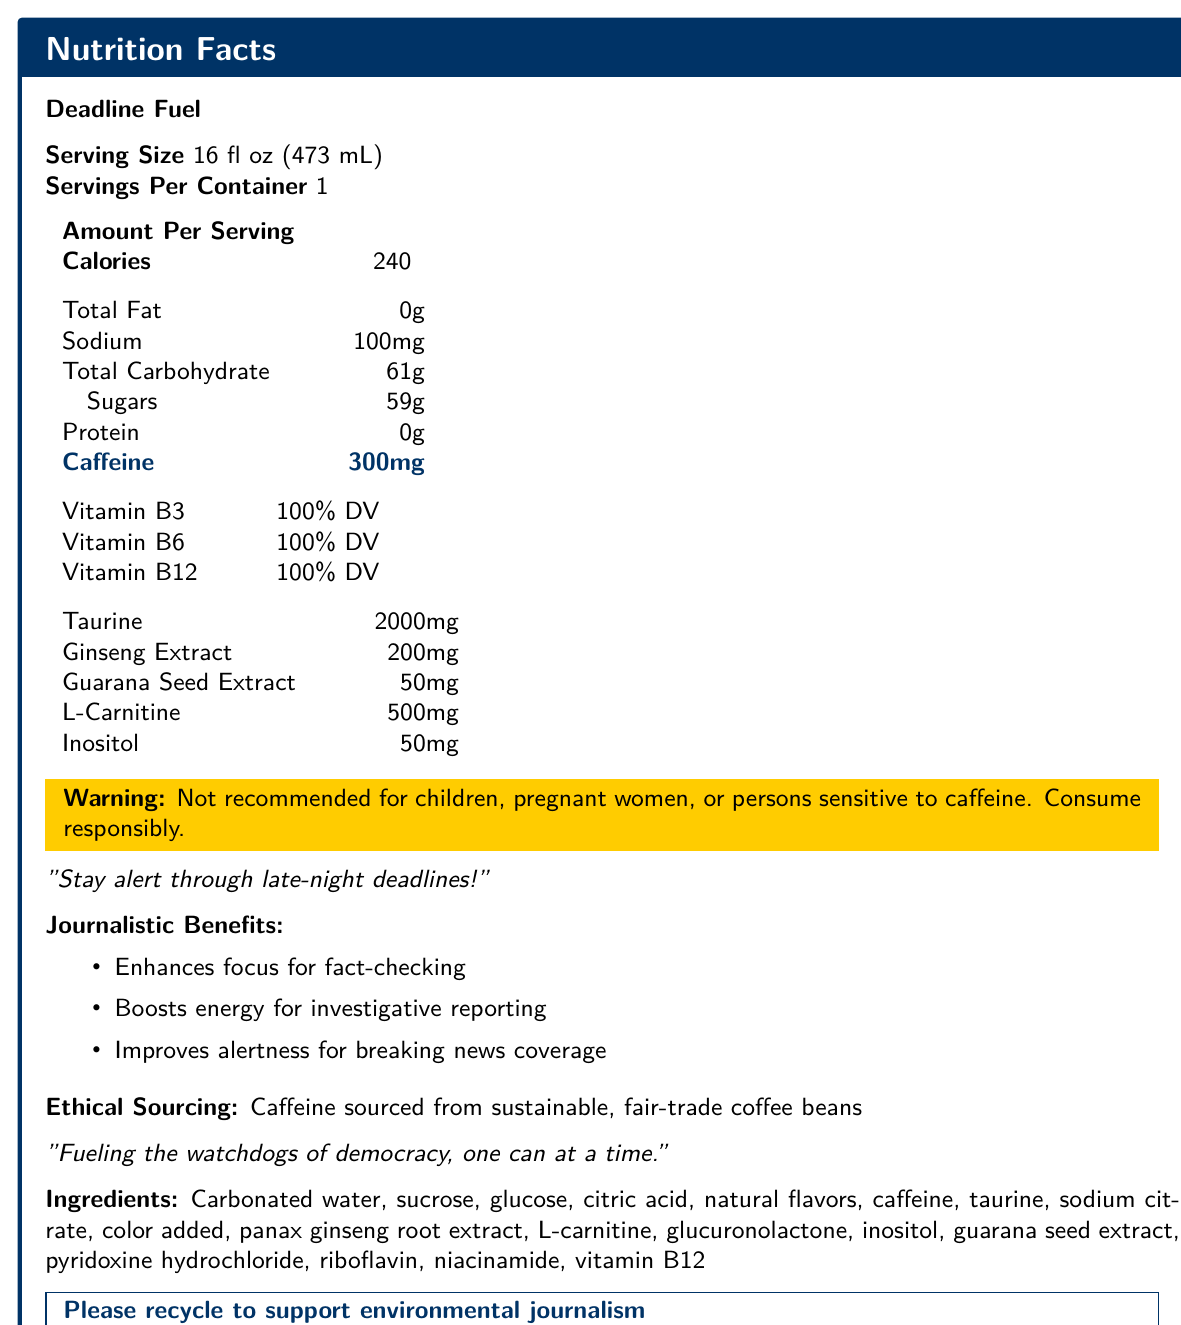what is the serving size of Deadline Fuel? The serving size is provided in the initial section of the Nutrition Facts label and reads 16 fl oz (473 mL).
Answer: 16 fl oz (473 mL) how many calories are there per serving? The amount of calories per serving is specifically listed in the section titled "Amount Per Serving."
Answer: 240 calories what is the caffeine content per serving? The caffeine content is highlighted in blue text under the "Amount Per Serving" section.
Answer: 300 mg what are two main journalistic benefits mentioned for Deadline Fuel? These benefits are listed under the section titled "Journalistic Benefits."
Answer: Enhances focus for fact-checking and Boosts energy for investigative reporting how much sodium is in a serving of Deadline Fuel? The sodium content is listed under "Amount Per Serving" in milligrams (mg).
Answer: 100 mg what is the warning provided on the label? The warning is highlighted in yellow and clearly specified on the label.
Answer: Not recommended for children, pregnant women, or persons sensitive to caffeine. Consume responsibly. what is the ethical sourcing statement on the label? This statement is located towards the bottom part of the document under the section "Ethical Sourcing."
Answer: Caffeine sourced from sustainable, fair-trade coffee beans what is the main ingredient in Deadline Fuel? A. Caffeine B. Carbonated water C. Taurine D. Ginseng extract The main ingredient listed first in the ingredients section is Carbonated water.
Answer: B. Carbonated water how many grams of sugar are in Deadline Fuel? A. 50 grams B. 59 grams C. 61 grams D. 100 grams The sugars content listed under "Amount Per Serving" is 59 grams.
Answer: B. 59 grams which vitamins are provided at 100% DV in Deadline Fuel? A. Vitamin B1, Vitamin B6, Vitamin E B. Vitamin C, Vitamin D, Vitamin B12 C. Vitamin B3, Vitamin B6, Vitamin B12 D. Vitamin A, Vitamin K, Vitamin B9 These vitamins are listed under a section with 100% DV next to their names.
Answer: C. Vitamin B3, Vitamin B6, Vitamin B12 is Deadline Fuel recommended for children? The warning section clearly states that it is not recommended for children.
Answer: No provide a summary of the Nutrition Facts Label for Deadline Fuel. The summary encapsulates the main details provided in the Nutrition Facts Label including nutritional content, key ingredients, warnings, and ethical sourcing statements.
Answer: Deadline Fuel is an energy drink with a serving size of 16 fl oz (473 mL) per container. It contains 240 calories, has 0g of total fat, 100mg of sodium, 61g of total carbohydrates including 59g of sugars, and 0g of protein. Notably, it has a high caffeine content of 300mg. It also provides 100% of the daily value of vitamins B3, B6, and B12. The drink contains additional ingredients like taurine (2000mg), ginseng extract (200mg), guarana seed extract (50mg), L-carnitine (500mg), and inositol (50mg). The label includes warnings and promotes ethical sourcing. how much taurine is included in Deadline Fuel? The amount of taurine is listed under the detailed ingredients section, showing as 2000 mg.
Answer: 2000 mg how is caffeine sourced for Deadline Fuel? This information is found in the "Ethical Sourcing" section of the label.
Answer: From sustainable, fair-trade coffee beans what additional compounds found in Deadline Fuel are known to enhance energy? I. Taurine II. Ginseng Extract III. Guarana Seed Extract IV. L-Carnitine All listed compounds known for energy enhancement are mentioned in the detailed ingredients section.
Answer: I, II, III, and IV what specific benefit does Deadline Fuel offer for breaking news coverage? Under the "Journalistic Benefits" section, it is specified that Deadline Fuel improves alertness for breaking news coverage.
Answer: Improves alertness who is the target audience for Deadline Fuel? The product is marketed specifically to journalists through its benefits and tagline.
Answer: Journalists explain the environmental call-to-action included on the label. The call-to-action to recycle is clearly indicated toward the bottom of the label with an explanation linking recycling to supporting environmental journalism.
Answer: Deadline Fuel urges consumers to recycle the can to support environmental journalism, highlighted in a special section of the document. how many servings are there per container of Deadline Fuel? The label specifies that there is one serving per container.
Answer: 1 who can safely consume Deadline Fuel without risk? The label specifically mentions who should not consume it but does not explicitly state who can safely consume it without risk.
Answer: Cannot be determined 